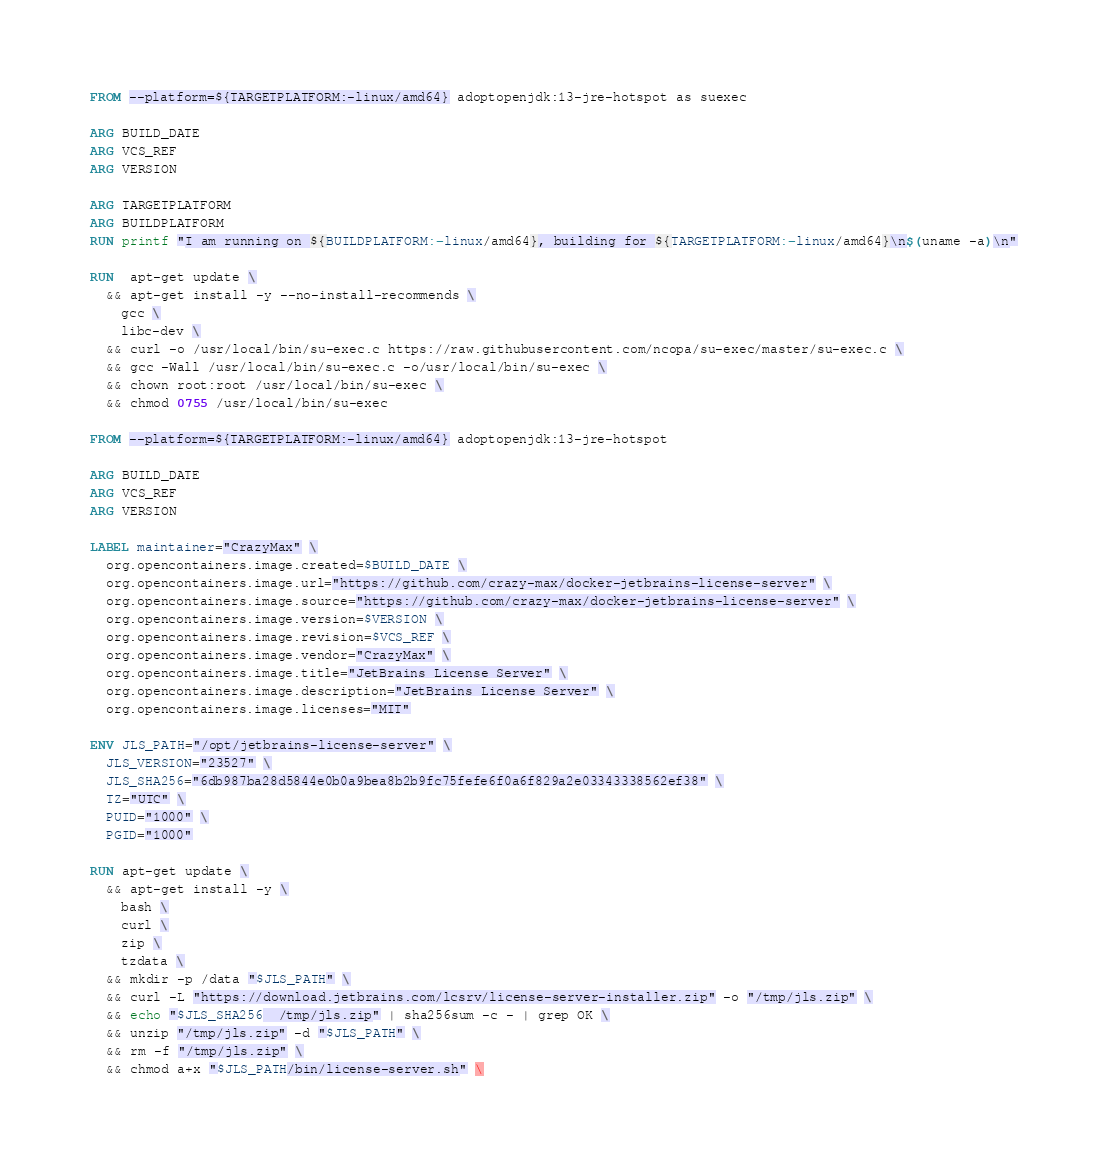Convert code to text. <code><loc_0><loc_0><loc_500><loc_500><_Dockerfile_>FROM --platform=${TARGETPLATFORM:-linux/amd64} adoptopenjdk:13-jre-hotspot as suexec

ARG BUILD_DATE
ARG VCS_REF
ARG VERSION

ARG TARGETPLATFORM
ARG BUILDPLATFORM
RUN printf "I am running on ${BUILDPLATFORM:-linux/amd64}, building for ${TARGETPLATFORM:-linux/amd64}\n$(uname -a)\n"

RUN  apt-get update \
  && apt-get install -y --no-install-recommends \
    gcc \
    libc-dev \
  && curl -o /usr/local/bin/su-exec.c https://raw.githubusercontent.com/ncopa/su-exec/master/su-exec.c \
  && gcc -Wall /usr/local/bin/su-exec.c -o/usr/local/bin/su-exec \
  && chown root:root /usr/local/bin/su-exec \
  && chmod 0755 /usr/local/bin/su-exec

FROM --platform=${TARGETPLATFORM:-linux/amd64} adoptopenjdk:13-jre-hotspot

ARG BUILD_DATE
ARG VCS_REF
ARG VERSION

LABEL maintainer="CrazyMax" \
  org.opencontainers.image.created=$BUILD_DATE \
  org.opencontainers.image.url="https://github.com/crazy-max/docker-jetbrains-license-server" \
  org.opencontainers.image.source="https://github.com/crazy-max/docker-jetbrains-license-server" \
  org.opencontainers.image.version=$VERSION \
  org.opencontainers.image.revision=$VCS_REF \
  org.opencontainers.image.vendor="CrazyMax" \
  org.opencontainers.image.title="JetBrains License Server" \
  org.opencontainers.image.description="JetBrains License Server" \
  org.opencontainers.image.licenses="MIT"

ENV JLS_PATH="/opt/jetbrains-license-server" \
  JLS_VERSION="23527" \
  JLS_SHA256="6db987ba28d5844e0b0a9bea8b2b9fc75fefe6f0a6f829a2e03343338562ef38" \
  TZ="UTC" \
  PUID="1000" \
  PGID="1000"

RUN apt-get update \
  && apt-get install -y \
    bash \
    curl \
    zip \
    tzdata \
  && mkdir -p /data "$JLS_PATH" \
  && curl -L "https://download.jetbrains.com/lcsrv/license-server-installer.zip" -o "/tmp/jls.zip" \
  && echo "$JLS_SHA256  /tmp/jls.zip" | sha256sum -c - | grep OK \
  && unzip "/tmp/jls.zip" -d "$JLS_PATH" \
  && rm -f "/tmp/jls.zip" \
  && chmod a+x "$JLS_PATH/bin/license-server.sh" \</code> 